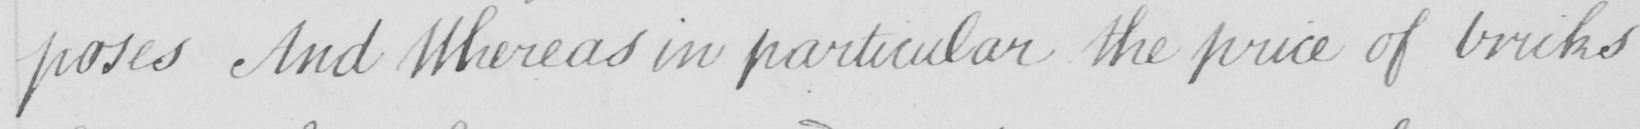What text is written in this handwritten line? -poses And Whereas in praticular the price of bricks 